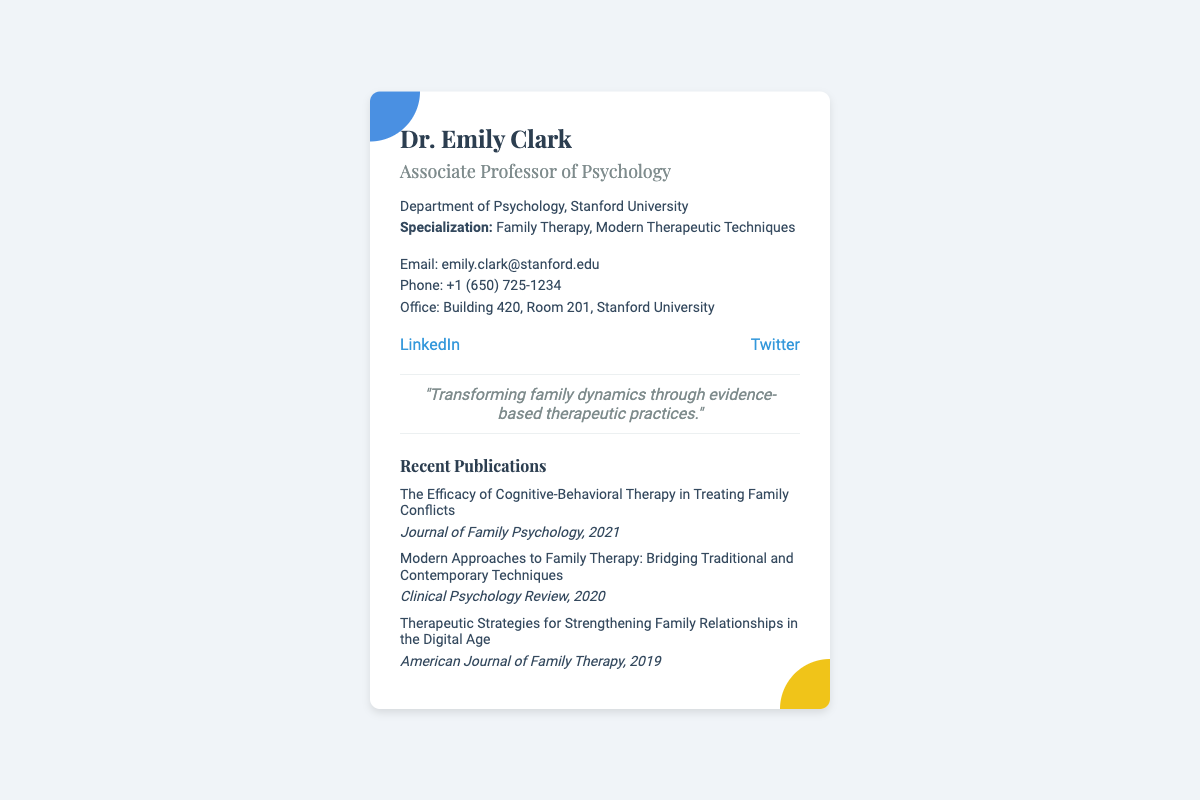What is the name of the professor? The name mentioned in the document is Dr. Emily Clark.
Answer: Dr. Emily Clark What is Dr. Clark's role at Stanford University? The document states that Dr. Clark is an Associate Professor of Psychology.
Answer: Associate Professor of Psychology Which department does Dr. Clark belong to? The document indicates that she is from the Department of Psychology.
Answer: Department of Psychology What is one of Dr. Clark's specializations? The document lists Family Therapy as one of her specializations.
Answer: Family Therapy What is Dr. Clark's contact email? The email address provided in the document is emily.clark@stanford.edu.
Answer: emily.clark@stanford.edu What quote is associated with Dr. Clark? The document features the quote "Transforming family dynamics through evidence-based therapeutic practices."
Answer: "Transforming family dynamics through evidence-based therapeutic practices." How many recent publications are listed? The document lists three recent publications.
Answer: Three In which year was the publication on Cognitive-Behavioral Therapy released? The document states that the publication was released in 2021.
Answer: 2021 What is one social media platform linked to Dr. Clark? The document includes a link to LinkedIn as one social media platform.
Answer: LinkedIn 